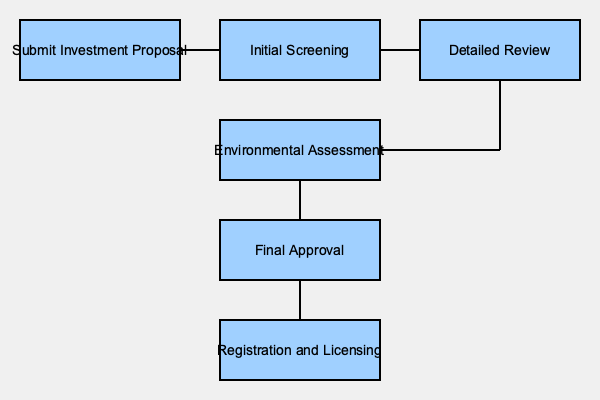According to the flowchart, which step immediately follows the "Detailed Review" in the investment approval process for foreign entrepreneurs in China's construction industry? The flowchart illustrates the investment approval process for foreign entrepreneurs in China's construction industry. To answer this question, we need to follow the steps in the diagram:

1. The process starts with "Submit Investment Proposal".
2. It then moves to "Initial Screening".
3. After initial screening, the proposal goes through "Detailed Review".
4. From the "Detailed Review" box, there's an arrow pointing downwards and then to the left.
5. This arrow leads to the "Environmental Assessment" step.
6. After the environmental assessment, the process continues with "Final Approval" and then "Registration and Licensing".

Therefore, based on the flowchart, the step that immediately follows the "Detailed Review" is the "Environmental Assessment".
Answer: Environmental Assessment 